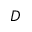<formula> <loc_0><loc_0><loc_500><loc_500>D</formula> 